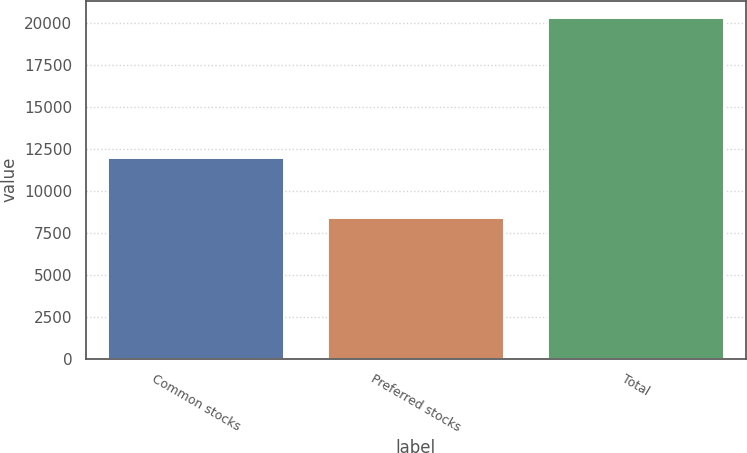<chart> <loc_0><loc_0><loc_500><loc_500><bar_chart><fcel>Common stocks<fcel>Preferred stocks<fcel>Total<nl><fcel>11929<fcel>8385<fcel>20314<nl></chart> 